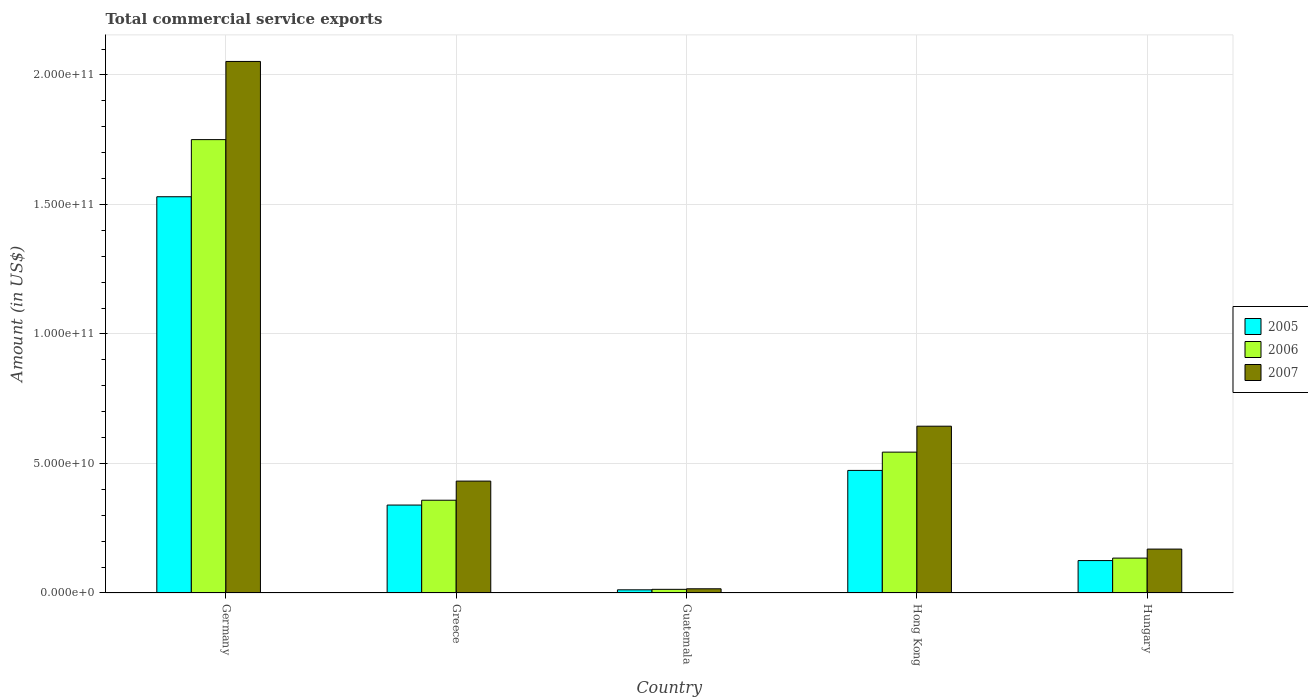What is the total commercial service exports in 2007 in Hungary?
Make the answer very short. 1.69e+1. Across all countries, what is the maximum total commercial service exports in 2007?
Offer a very short reply. 2.05e+11. Across all countries, what is the minimum total commercial service exports in 2005?
Make the answer very short. 1.22e+09. In which country was the total commercial service exports in 2007 minimum?
Provide a succinct answer. Guatemala. What is the total total commercial service exports in 2007 in the graph?
Your response must be concise. 3.31e+11. What is the difference between the total commercial service exports in 2007 in Germany and that in Greece?
Ensure brevity in your answer.  1.62e+11. What is the difference between the total commercial service exports in 2005 in Hungary and the total commercial service exports in 2006 in Guatemala?
Your answer should be very brief. 1.11e+1. What is the average total commercial service exports in 2006 per country?
Make the answer very short. 5.60e+1. What is the difference between the total commercial service exports of/in 2006 and total commercial service exports of/in 2007 in Guatemala?
Your response must be concise. -2.09e+08. In how many countries, is the total commercial service exports in 2006 greater than 70000000000 US$?
Your answer should be very brief. 1. What is the ratio of the total commercial service exports in 2007 in Greece to that in Guatemala?
Keep it short and to the point. 26.67. Is the total commercial service exports in 2006 in Germany less than that in Hong Kong?
Make the answer very short. No. What is the difference between the highest and the second highest total commercial service exports in 2007?
Provide a short and direct response. 1.41e+11. What is the difference between the highest and the lowest total commercial service exports in 2006?
Provide a short and direct response. 1.74e+11. Is the sum of the total commercial service exports in 2006 in Greece and Hungary greater than the maximum total commercial service exports in 2007 across all countries?
Keep it short and to the point. No. Are all the bars in the graph horizontal?
Your answer should be compact. No. What is the difference between two consecutive major ticks on the Y-axis?
Keep it short and to the point. 5.00e+1. Are the values on the major ticks of Y-axis written in scientific E-notation?
Your response must be concise. Yes. Does the graph contain grids?
Ensure brevity in your answer.  Yes. What is the title of the graph?
Provide a succinct answer. Total commercial service exports. Does "2000" appear as one of the legend labels in the graph?
Offer a terse response. No. What is the label or title of the Y-axis?
Ensure brevity in your answer.  Amount (in US$). What is the Amount (in US$) in 2005 in Germany?
Your answer should be very brief. 1.53e+11. What is the Amount (in US$) of 2006 in Germany?
Your response must be concise. 1.75e+11. What is the Amount (in US$) of 2007 in Germany?
Your answer should be compact. 2.05e+11. What is the Amount (in US$) in 2005 in Greece?
Your answer should be very brief. 3.39e+1. What is the Amount (in US$) of 2006 in Greece?
Offer a terse response. 3.58e+1. What is the Amount (in US$) of 2007 in Greece?
Provide a short and direct response. 4.32e+1. What is the Amount (in US$) of 2005 in Guatemala?
Give a very brief answer. 1.22e+09. What is the Amount (in US$) of 2006 in Guatemala?
Provide a short and direct response. 1.41e+09. What is the Amount (in US$) in 2007 in Guatemala?
Your answer should be compact. 1.62e+09. What is the Amount (in US$) in 2005 in Hong Kong?
Make the answer very short. 4.73e+1. What is the Amount (in US$) of 2006 in Hong Kong?
Provide a succinct answer. 5.44e+1. What is the Amount (in US$) in 2007 in Hong Kong?
Give a very brief answer. 6.44e+1. What is the Amount (in US$) of 2005 in Hungary?
Keep it short and to the point. 1.25e+1. What is the Amount (in US$) in 2006 in Hungary?
Your answer should be very brief. 1.35e+1. What is the Amount (in US$) of 2007 in Hungary?
Your answer should be very brief. 1.69e+1. Across all countries, what is the maximum Amount (in US$) of 2005?
Give a very brief answer. 1.53e+11. Across all countries, what is the maximum Amount (in US$) of 2006?
Keep it short and to the point. 1.75e+11. Across all countries, what is the maximum Amount (in US$) of 2007?
Your answer should be very brief. 2.05e+11. Across all countries, what is the minimum Amount (in US$) of 2005?
Give a very brief answer. 1.22e+09. Across all countries, what is the minimum Amount (in US$) in 2006?
Offer a terse response. 1.41e+09. Across all countries, what is the minimum Amount (in US$) of 2007?
Provide a short and direct response. 1.62e+09. What is the total Amount (in US$) in 2005 in the graph?
Offer a very short reply. 2.48e+11. What is the total Amount (in US$) of 2006 in the graph?
Give a very brief answer. 2.80e+11. What is the total Amount (in US$) in 2007 in the graph?
Provide a short and direct response. 3.31e+11. What is the difference between the Amount (in US$) in 2005 in Germany and that in Greece?
Your response must be concise. 1.19e+11. What is the difference between the Amount (in US$) in 2006 in Germany and that in Greece?
Keep it short and to the point. 1.39e+11. What is the difference between the Amount (in US$) of 2007 in Germany and that in Greece?
Give a very brief answer. 1.62e+11. What is the difference between the Amount (in US$) in 2005 in Germany and that in Guatemala?
Make the answer very short. 1.52e+11. What is the difference between the Amount (in US$) of 2006 in Germany and that in Guatemala?
Give a very brief answer. 1.74e+11. What is the difference between the Amount (in US$) in 2007 in Germany and that in Guatemala?
Give a very brief answer. 2.04e+11. What is the difference between the Amount (in US$) of 2005 in Germany and that in Hong Kong?
Provide a succinct answer. 1.06e+11. What is the difference between the Amount (in US$) of 2006 in Germany and that in Hong Kong?
Offer a terse response. 1.21e+11. What is the difference between the Amount (in US$) of 2007 in Germany and that in Hong Kong?
Ensure brevity in your answer.  1.41e+11. What is the difference between the Amount (in US$) in 2005 in Germany and that in Hungary?
Give a very brief answer. 1.40e+11. What is the difference between the Amount (in US$) of 2006 in Germany and that in Hungary?
Offer a terse response. 1.62e+11. What is the difference between the Amount (in US$) of 2007 in Germany and that in Hungary?
Offer a terse response. 1.88e+11. What is the difference between the Amount (in US$) of 2005 in Greece and that in Guatemala?
Make the answer very short. 3.27e+1. What is the difference between the Amount (in US$) in 2006 in Greece and that in Guatemala?
Offer a very short reply. 3.44e+1. What is the difference between the Amount (in US$) in 2007 in Greece and that in Guatemala?
Offer a terse response. 4.16e+1. What is the difference between the Amount (in US$) in 2005 in Greece and that in Hong Kong?
Provide a succinct answer. -1.34e+1. What is the difference between the Amount (in US$) of 2006 in Greece and that in Hong Kong?
Provide a short and direct response. -1.86e+1. What is the difference between the Amount (in US$) of 2007 in Greece and that in Hong Kong?
Your answer should be very brief. -2.12e+1. What is the difference between the Amount (in US$) of 2005 in Greece and that in Hungary?
Offer a terse response. 2.14e+1. What is the difference between the Amount (in US$) of 2006 in Greece and that in Hungary?
Offer a very short reply. 2.23e+1. What is the difference between the Amount (in US$) of 2007 in Greece and that in Hungary?
Ensure brevity in your answer.  2.62e+1. What is the difference between the Amount (in US$) in 2005 in Guatemala and that in Hong Kong?
Offer a very short reply. -4.61e+1. What is the difference between the Amount (in US$) in 2006 in Guatemala and that in Hong Kong?
Offer a terse response. -5.30e+1. What is the difference between the Amount (in US$) of 2007 in Guatemala and that in Hong Kong?
Offer a terse response. -6.28e+1. What is the difference between the Amount (in US$) in 2005 in Guatemala and that in Hungary?
Keep it short and to the point. -1.13e+1. What is the difference between the Amount (in US$) in 2006 in Guatemala and that in Hungary?
Your answer should be very brief. -1.21e+1. What is the difference between the Amount (in US$) of 2007 in Guatemala and that in Hungary?
Offer a terse response. -1.53e+1. What is the difference between the Amount (in US$) of 2005 in Hong Kong and that in Hungary?
Ensure brevity in your answer.  3.48e+1. What is the difference between the Amount (in US$) in 2006 in Hong Kong and that in Hungary?
Your answer should be compact. 4.09e+1. What is the difference between the Amount (in US$) of 2007 in Hong Kong and that in Hungary?
Your answer should be very brief. 4.74e+1. What is the difference between the Amount (in US$) in 2005 in Germany and the Amount (in US$) in 2006 in Greece?
Your answer should be compact. 1.17e+11. What is the difference between the Amount (in US$) of 2005 in Germany and the Amount (in US$) of 2007 in Greece?
Give a very brief answer. 1.10e+11. What is the difference between the Amount (in US$) of 2006 in Germany and the Amount (in US$) of 2007 in Greece?
Ensure brevity in your answer.  1.32e+11. What is the difference between the Amount (in US$) in 2005 in Germany and the Amount (in US$) in 2006 in Guatemala?
Give a very brief answer. 1.52e+11. What is the difference between the Amount (in US$) of 2005 in Germany and the Amount (in US$) of 2007 in Guatemala?
Give a very brief answer. 1.51e+11. What is the difference between the Amount (in US$) of 2006 in Germany and the Amount (in US$) of 2007 in Guatemala?
Your answer should be very brief. 1.73e+11. What is the difference between the Amount (in US$) in 2005 in Germany and the Amount (in US$) in 2006 in Hong Kong?
Ensure brevity in your answer.  9.86e+1. What is the difference between the Amount (in US$) of 2005 in Germany and the Amount (in US$) of 2007 in Hong Kong?
Your response must be concise. 8.86e+1. What is the difference between the Amount (in US$) in 2006 in Germany and the Amount (in US$) in 2007 in Hong Kong?
Make the answer very short. 1.11e+11. What is the difference between the Amount (in US$) in 2005 in Germany and the Amount (in US$) in 2006 in Hungary?
Provide a short and direct response. 1.40e+11. What is the difference between the Amount (in US$) in 2005 in Germany and the Amount (in US$) in 2007 in Hungary?
Give a very brief answer. 1.36e+11. What is the difference between the Amount (in US$) of 2006 in Germany and the Amount (in US$) of 2007 in Hungary?
Your answer should be compact. 1.58e+11. What is the difference between the Amount (in US$) in 2005 in Greece and the Amount (in US$) in 2006 in Guatemala?
Your response must be concise. 3.25e+1. What is the difference between the Amount (in US$) in 2005 in Greece and the Amount (in US$) in 2007 in Guatemala?
Provide a short and direct response. 3.23e+1. What is the difference between the Amount (in US$) in 2006 in Greece and the Amount (in US$) in 2007 in Guatemala?
Make the answer very short. 3.42e+1. What is the difference between the Amount (in US$) of 2005 in Greece and the Amount (in US$) of 2006 in Hong Kong?
Ensure brevity in your answer.  -2.04e+1. What is the difference between the Amount (in US$) of 2005 in Greece and the Amount (in US$) of 2007 in Hong Kong?
Offer a terse response. -3.04e+1. What is the difference between the Amount (in US$) in 2006 in Greece and the Amount (in US$) in 2007 in Hong Kong?
Your response must be concise. -2.86e+1. What is the difference between the Amount (in US$) in 2005 in Greece and the Amount (in US$) in 2006 in Hungary?
Offer a terse response. 2.05e+1. What is the difference between the Amount (in US$) of 2005 in Greece and the Amount (in US$) of 2007 in Hungary?
Offer a very short reply. 1.70e+1. What is the difference between the Amount (in US$) of 2006 in Greece and the Amount (in US$) of 2007 in Hungary?
Provide a short and direct response. 1.89e+1. What is the difference between the Amount (in US$) of 2005 in Guatemala and the Amount (in US$) of 2006 in Hong Kong?
Provide a short and direct response. -5.32e+1. What is the difference between the Amount (in US$) of 2005 in Guatemala and the Amount (in US$) of 2007 in Hong Kong?
Offer a terse response. -6.32e+1. What is the difference between the Amount (in US$) in 2006 in Guatemala and the Amount (in US$) in 2007 in Hong Kong?
Your answer should be very brief. -6.30e+1. What is the difference between the Amount (in US$) of 2005 in Guatemala and the Amount (in US$) of 2006 in Hungary?
Offer a very short reply. -1.22e+1. What is the difference between the Amount (in US$) of 2005 in Guatemala and the Amount (in US$) of 2007 in Hungary?
Provide a succinct answer. -1.57e+1. What is the difference between the Amount (in US$) in 2006 in Guatemala and the Amount (in US$) in 2007 in Hungary?
Make the answer very short. -1.55e+1. What is the difference between the Amount (in US$) in 2005 in Hong Kong and the Amount (in US$) in 2006 in Hungary?
Ensure brevity in your answer.  3.39e+1. What is the difference between the Amount (in US$) of 2005 in Hong Kong and the Amount (in US$) of 2007 in Hungary?
Your answer should be very brief. 3.04e+1. What is the difference between the Amount (in US$) in 2006 in Hong Kong and the Amount (in US$) in 2007 in Hungary?
Your response must be concise. 3.74e+1. What is the average Amount (in US$) in 2005 per country?
Offer a very short reply. 4.96e+1. What is the average Amount (in US$) in 2006 per country?
Your answer should be very brief. 5.60e+1. What is the average Amount (in US$) in 2007 per country?
Provide a succinct answer. 6.63e+1. What is the difference between the Amount (in US$) in 2005 and Amount (in US$) in 2006 in Germany?
Give a very brief answer. -2.21e+1. What is the difference between the Amount (in US$) in 2005 and Amount (in US$) in 2007 in Germany?
Offer a terse response. -5.22e+1. What is the difference between the Amount (in US$) of 2006 and Amount (in US$) of 2007 in Germany?
Keep it short and to the point. -3.02e+1. What is the difference between the Amount (in US$) of 2005 and Amount (in US$) of 2006 in Greece?
Ensure brevity in your answer.  -1.86e+09. What is the difference between the Amount (in US$) in 2005 and Amount (in US$) in 2007 in Greece?
Keep it short and to the point. -9.25e+09. What is the difference between the Amount (in US$) of 2006 and Amount (in US$) of 2007 in Greece?
Your response must be concise. -7.38e+09. What is the difference between the Amount (in US$) of 2005 and Amount (in US$) of 2006 in Guatemala?
Ensure brevity in your answer.  -1.89e+08. What is the difference between the Amount (in US$) of 2005 and Amount (in US$) of 2007 in Guatemala?
Offer a terse response. -3.98e+08. What is the difference between the Amount (in US$) of 2006 and Amount (in US$) of 2007 in Guatemala?
Your response must be concise. -2.09e+08. What is the difference between the Amount (in US$) in 2005 and Amount (in US$) in 2006 in Hong Kong?
Your answer should be very brief. -7.06e+09. What is the difference between the Amount (in US$) in 2005 and Amount (in US$) in 2007 in Hong Kong?
Your answer should be very brief. -1.71e+1. What is the difference between the Amount (in US$) of 2006 and Amount (in US$) of 2007 in Hong Kong?
Your answer should be very brief. -1.00e+1. What is the difference between the Amount (in US$) of 2005 and Amount (in US$) of 2006 in Hungary?
Offer a terse response. -9.54e+08. What is the difference between the Amount (in US$) of 2005 and Amount (in US$) of 2007 in Hungary?
Your response must be concise. -4.43e+09. What is the difference between the Amount (in US$) in 2006 and Amount (in US$) in 2007 in Hungary?
Make the answer very short. -3.48e+09. What is the ratio of the Amount (in US$) in 2005 in Germany to that in Greece?
Your answer should be compact. 4.51. What is the ratio of the Amount (in US$) of 2006 in Germany to that in Greece?
Provide a short and direct response. 4.89. What is the ratio of the Amount (in US$) of 2007 in Germany to that in Greece?
Offer a very short reply. 4.75. What is the ratio of the Amount (in US$) in 2005 in Germany to that in Guatemala?
Give a very brief answer. 125.25. What is the ratio of the Amount (in US$) of 2006 in Germany to that in Guatemala?
Your answer should be very brief. 124.11. What is the ratio of the Amount (in US$) in 2007 in Germany to that in Guatemala?
Your answer should be compact. 126.72. What is the ratio of the Amount (in US$) of 2005 in Germany to that in Hong Kong?
Ensure brevity in your answer.  3.23. What is the ratio of the Amount (in US$) of 2006 in Germany to that in Hong Kong?
Offer a terse response. 3.22. What is the ratio of the Amount (in US$) in 2007 in Germany to that in Hong Kong?
Ensure brevity in your answer.  3.19. What is the ratio of the Amount (in US$) in 2005 in Germany to that in Hungary?
Keep it short and to the point. 12.22. What is the ratio of the Amount (in US$) of 2006 in Germany to that in Hungary?
Your answer should be very brief. 12.99. What is the ratio of the Amount (in US$) of 2007 in Germany to that in Hungary?
Your answer should be very brief. 12.11. What is the ratio of the Amount (in US$) of 2005 in Greece to that in Guatemala?
Provide a succinct answer. 27.79. What is the ratio of the Amount (in US$) of 2006 in Greece to that in Guatemala?
Your answer should be compact. 25.39. What is the ratio of the Amount (in US$) of 2007 in Greece to that in Guatemala?
Provide a short and direct response. 26.67. What is the ratio of the Amount (in US$) in 2005 in Greece to that in Hong Kong?
Make the answer very short. 0.72. What is the ratio of the Amount (in US$) in 2006 in Greece to that in Hong Kong?
Provide a short and direct response. 0.66. What is the ratio of the Amount (in US$) of 2007 in Greece to that in Hong Kong?
Offer a very short reply. 0.67. What is the ratio of the Amount (in US$) in 2005 in Greece to that in Hungary?
Provide a succinct answer. 2.71. What is the ratio of the Amount (in US$) in 2006 in Greece to that in Hungary?
Keep it short and to the point. 2.66. What is the ratio of the Amount (in US$) in 2007 in Greece to that in Hungary?
Offer a terse response. 2.55. What is the ratio of the Amount (in US$) of 2005 in Guatemala to that in Hong Kong?
Ensure brevity in your answer.  0.03. What is the ratio of the Amount (in US$) of 2006 in Guatemala to that in Hong Kong?
Provide a succinct answer. 0.03. What is the ratio of the Amount (in US$) in 2007 in Guatemala to that in Hong Kong?
Give a very brief answer. 0.03. What is the ratio of the Amount (in US$) of 2005 in Guatemala to that in Hungary?
Keep it short and to the point. 0.1. What is the ratio of the Amount (in US$) of 2006 in Guatemala to that in Hungary?
Offer a terse response. 0.1. What is the ratio of the Amount (in US$) in 2007 in Guatemala to that in Hungary?
Make the answer very short. 0.1. What is the ratio of the Amount (in US$) of 2005 in Hong Kong to that in Hungary?
Make the answer very short. 3.78. What is the ratio of the Amount (in US$) of 2006 in Hong Kong to that in Hungary?
Your response must be concise. 4.04. What is the ratio of the Amount (in US$) of 2007 in Hong Kong to that in Hungary?
Keep it short and to the point. 3.8. What is the difference between the highest and the second highest Amount (in US$) in 2005?
Provide a short and direct response. 1.06e+11. What is the difference between the highest and the second highest Amount (in US$) of 2006?
Keep it short and to the point. 1.21e+11. What is the difference between the highest and the second highest Amount (in US$) in 2007?
Your answer should be compact. 1.41e+11. What is the difference between the highest and the lowest Amount (in US$) of 2005?
Make the answer very short. 1.52e+11. What is the difference between the highest and the lowest Amount (in US$) in 2006?
Provide a succinct answer. 1.74e+11. What is the difference between the highest and the lowest Amount (in US$) in 2007?
Your answer should be very brief. 2.04e+11. 